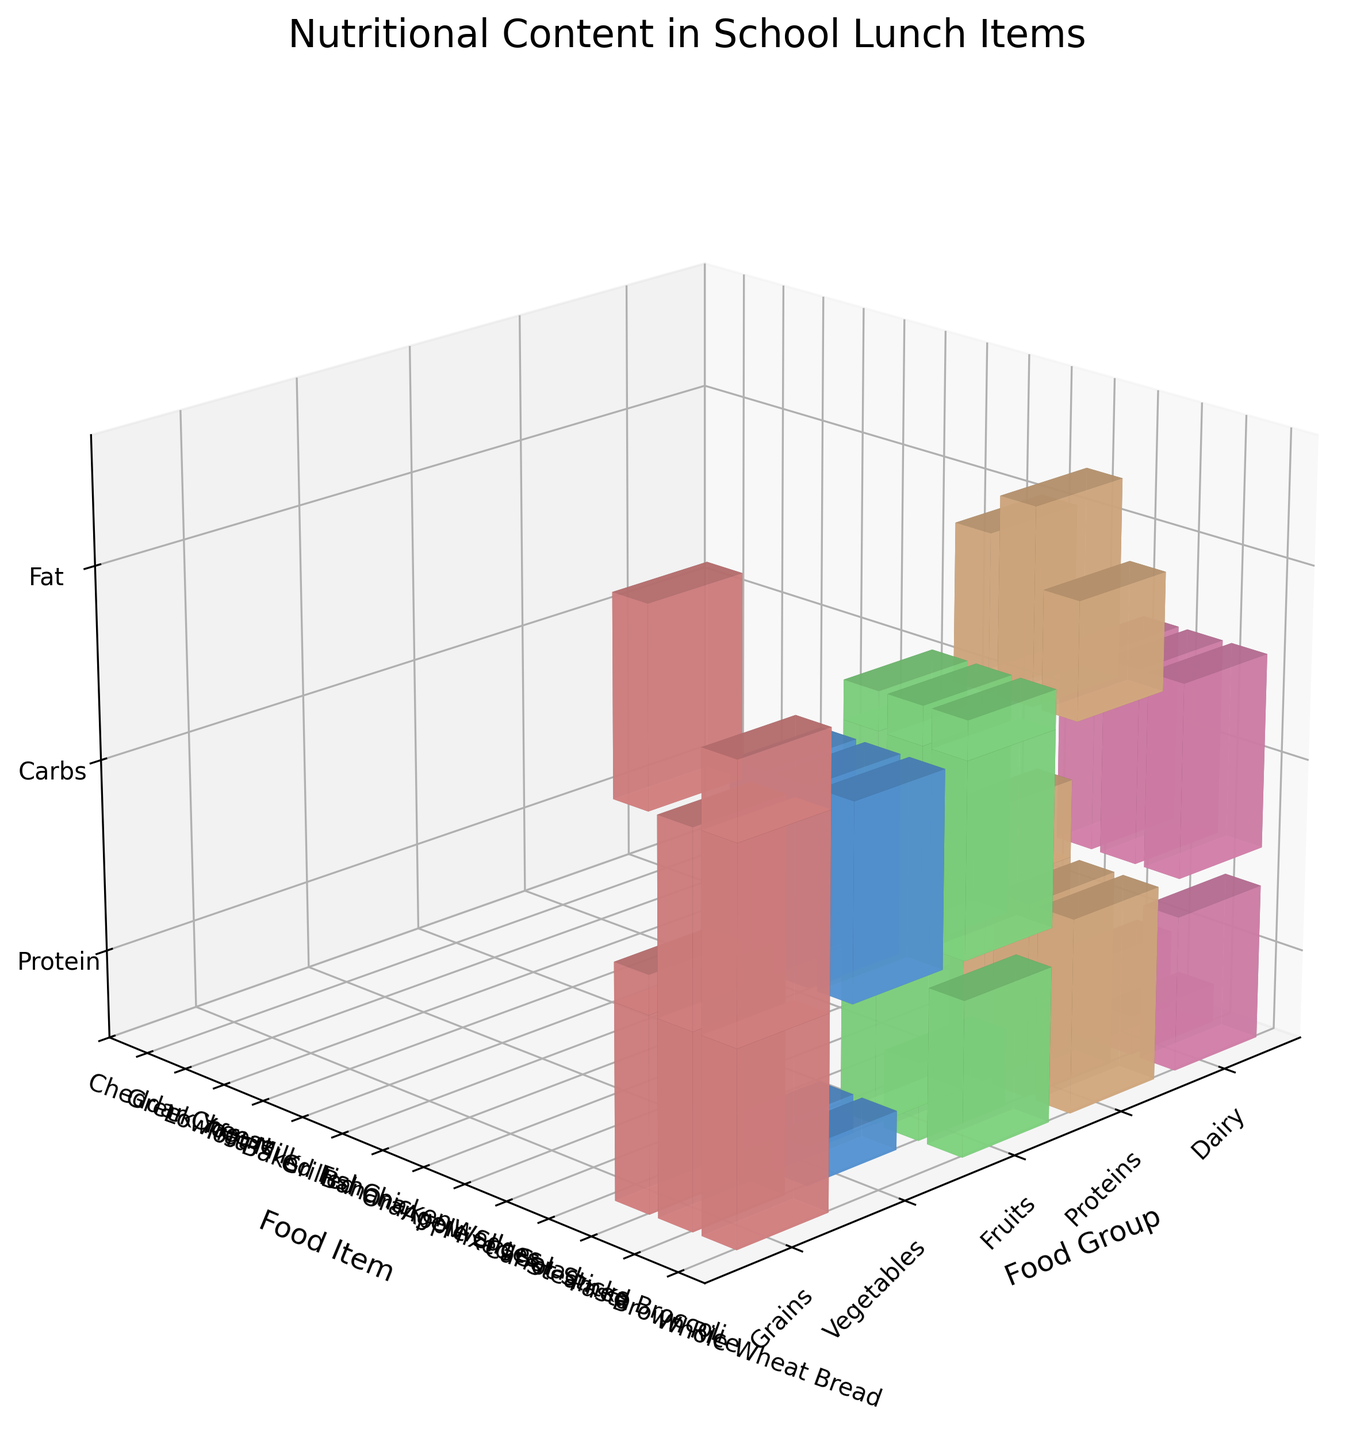What is the title of the figure? The title of any figure is usually located at the top. Here, the title is displayed prominently above the 3D voxel plot.
Answer: Nutritional Content in School Lunch Items How many food groups are represented in the plot? To determine the number of food groups, count the unique labels on the x-axis. The x-axis represents the food groups in this plot.
Answer: 4 Which food group has the highest protein content in any food item? The height of the bars along the protein z-axis can determine this. Grilled Chicken from the Proteins group reaches the highest point.
Answer: Proteins Are there any food items with zero carbohydrate content? If so, which ones? To determine this, look for food items where the carbohydrate bar is missing. Grilled Chicken, Baked Fish, and Tofu have no carbohydrate bar.
Answer: Grilled Chicken, Baked Fish, Tofu Which food item from the Grains group has the highest carbohydrate content? Identify the items within the Grains group and compare their carbohydrate bars. The highest bar for carbohydrates in the Grains group is for Pasta.
Answer: Pasta Between Baked Fish and Tofu, which has a higher fat content? Compare the height of the fat bars of Baked Fish and Tofu in the Proteins group. The Baked Fish bar is slightly higher than the Tofu bar.
Answer: Baked Fish How does the protein content of Greek Yogurt compare to Cheddar Cheese in the Dairy group? Compare the heights of the protein bars for Greek Yogurt and Cheddar Cheese within the Dairy group. Greek Yogurt has a higher protein bar.
Answer: Greek Yogurt has more protein Which food item from the Fruits group has the highest carbohydrate content? Within the Fruits group, compare the height of the carbohydrate bars for Apple Slices, Orange Wedges, and Banana. The Banana bar is the tallest.
Answer: Banana What is the range of protein content in the Dairy group? Locate the protein bars within the Dairy group and note their heights. The range is from the lowest protein count (Cheddar Cheese) to the highest (Greek Yogurt).
Answer: 7g to 15g Considering all food items, which one has the highest fat content? Scan all groups and compare the heights of the fat bars. Cheddar Cheese in the Dairy group has the tallest fat bar.
Answer: Cheddar Cheese 